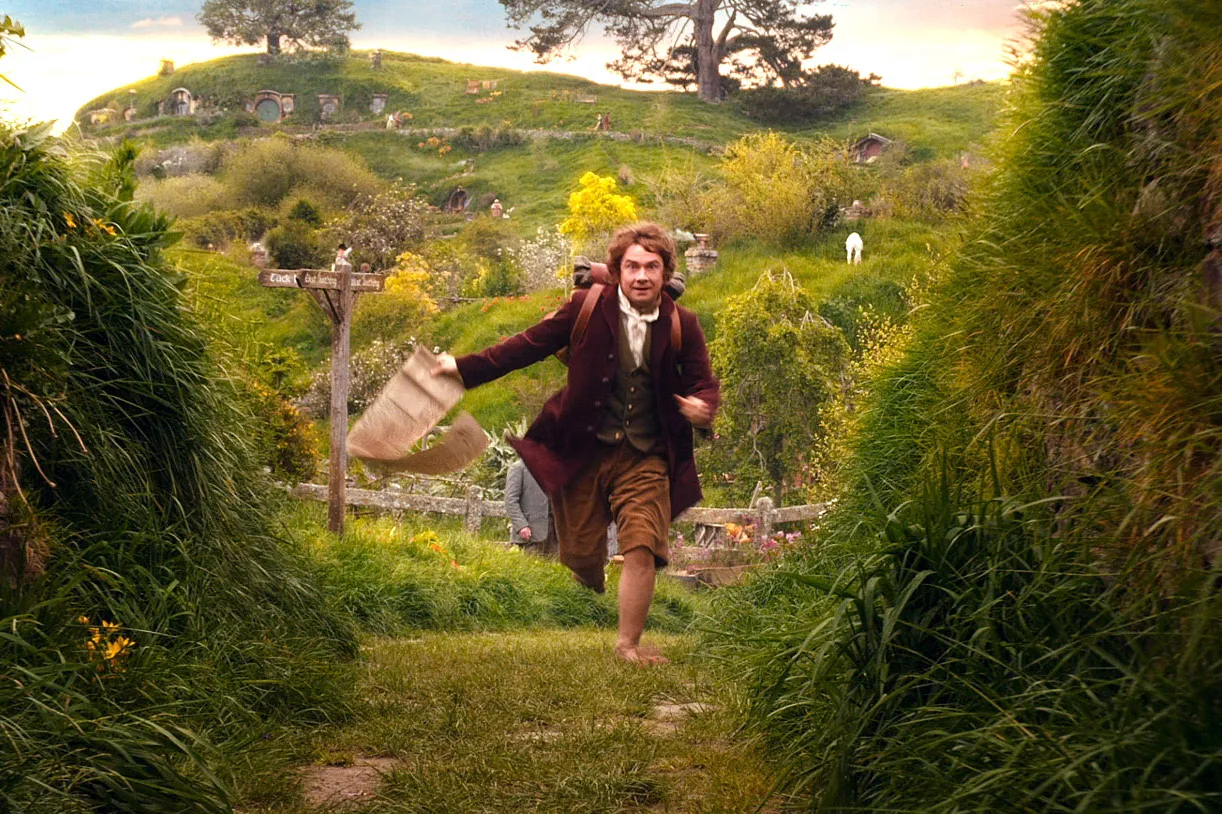What are the key elements in this picture? This image vividly captures a character, likely from a cinematic depiction of a fantastical tale, running energetically across a lush, verdant landscape dotted with unique, round-door hobbit homes characteristic of an idyllic village. He is dressed in a late 18th-century inspired outfit, rushing with a determined expression and clutching a bag, suggesting a moment of urgent adventure amidst the peaceful surroundings. A signpost prominently marked 'Bag End' subtly indicates the setting and adds a layer of narrative significance, hinting at an intriguing story unfolding within this serene hamlet. 